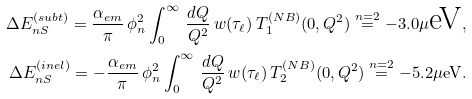Convert formula to latex. <formula><loc_0><loc_0><loc_500><loc_500>\Delta E ^ { ( s u b t ) } _ { n S } = \frac { \alpha _ { e m } } { \pi } \, \phi ^ { 2 } _ { n } \int _ { 0 } ^ { \infty } \, \frac { d Q } { Q ^ { 2 } } \, w ( \tau _ { \ell } ) \, T ^ { ( N B ) } _ { 1 } ( 0 , Q ^ { 2 } ) \stackrel { n = 2 } { = } - 3 . 0 \mu \text {eV} , \\ \Delta E ^ { ( i n e l ) } _ { n S } = - \frac { \alpha _ { e m } } { \pi } \, \phi ^ { 2 } _ { n } \int _ { 0 } ^ { \infty } \, \frac { d Q } { Q ^ { 2 } } \, w ( \tau _ { \ell } ) \, T ^ { ( N B ) } _ { 2 } ( 0 , Q ^ { 2 } ) \stackrel { n = 2 } { = } - 5 . 2 \mu \text {eV} .</formula> 